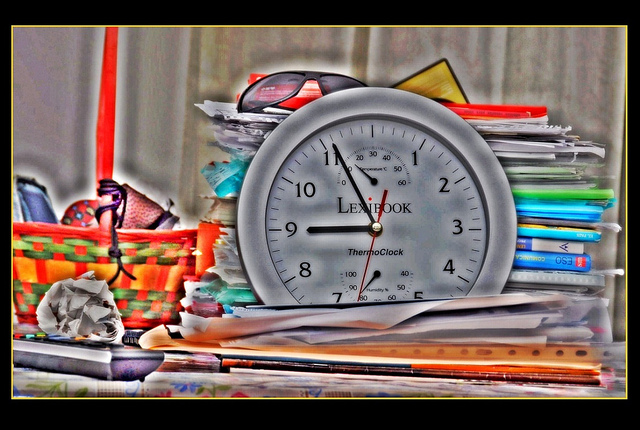Please transcribe the text in this image. 60 10 11 1 2 3 OSE 60 90 90 90 40 100 SO 40 30 4 C 7 LEXIBOOK TherrnoClock 8 9 